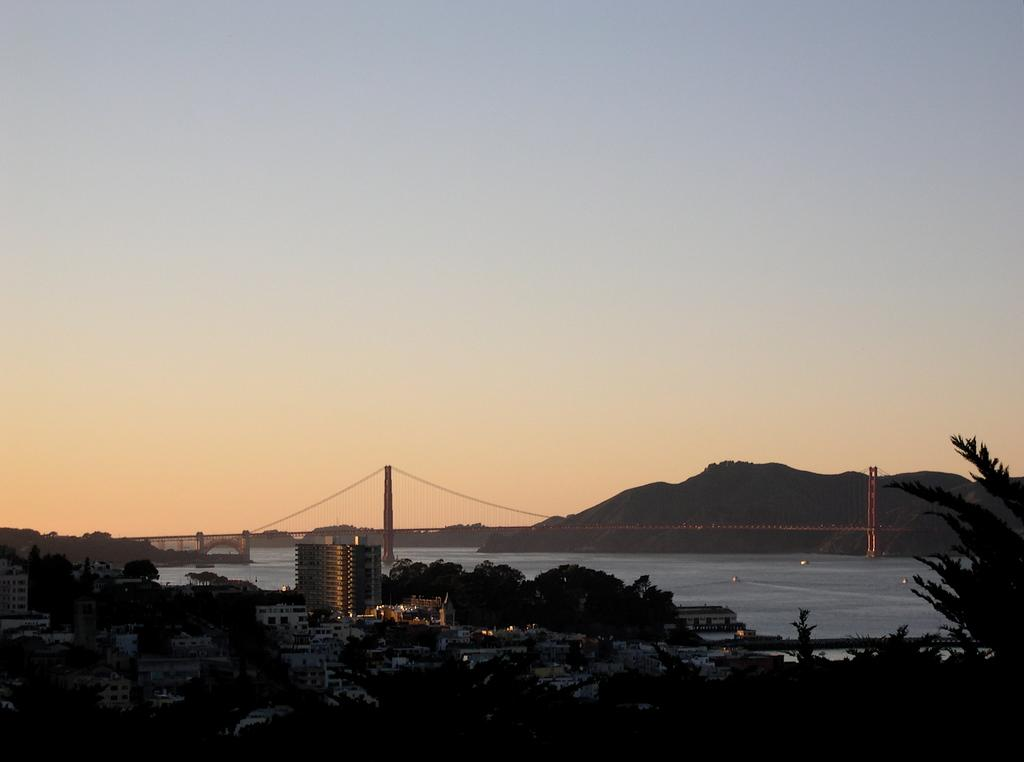What can be seen in the background of the image? In the background of the image, there is sky, hills, water, and a fence visible. What type of vegetation is present in the image? There are trees in the image. What type of structures can be seen in the image? There are buildings in the image. How would you describe the lighting in the bottom portion of the image? The bottom portion of the image is dark. What type of silver amusement ride can be seen near the water in the image? There is no amusement ride, silver or otherwise, present in the image. The image features hills, water, and a fence in the background, along with trees and buildings in the foreground. 